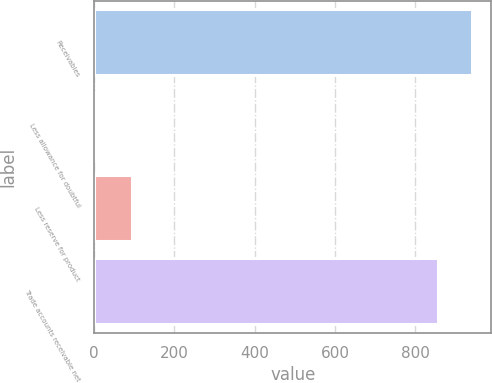Convert chart to OTSL. <chart><loc_0><loc_0><loc_500><loc_500><bar_chart><fcel>Receivables<fcel>Less allowance for doubtful<fcel>Less reserve for product<fcel>Trade accounts receivable net<nl><fcel>942.5<fcel>8<fcel>94.5<fcel>856<nl></chart> 